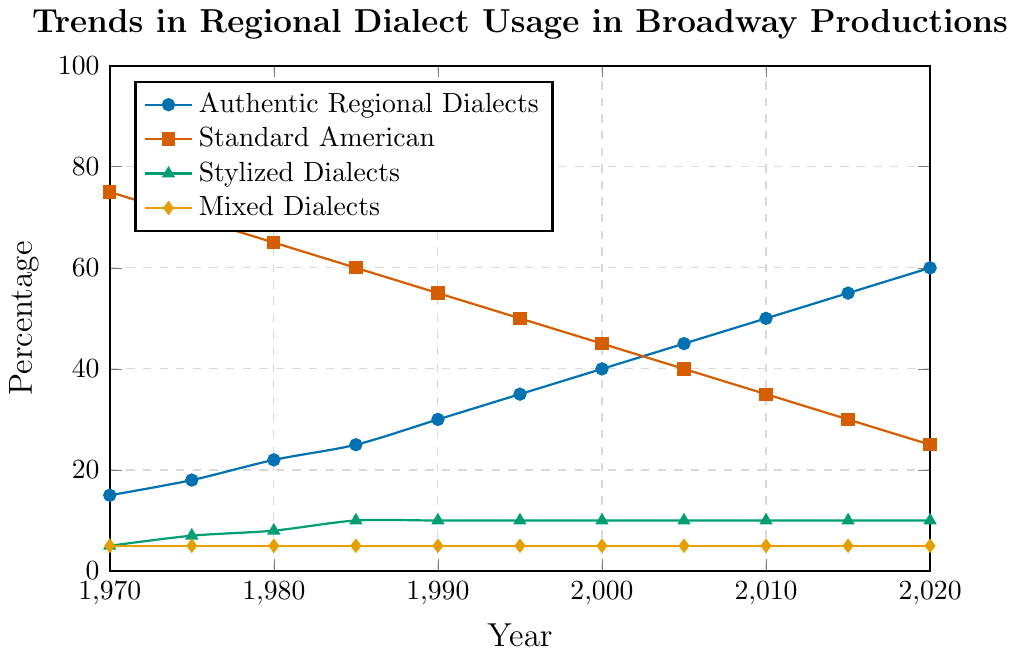What trend can be observed for the use of Authentic Regional Dialects from 1970 to 2020? The line representing Authentic Regional Dialects shows an upward trend, starting at 15% in 1970 and increasing steadily to 60% in 2020.
Answer: Increasing Which year did Standard American fall to 50% usage? The plot shows that Standard American usage was 50% in the year 1995.
Answer: 1995 Compare the usage of Stylized Dialects and Mixed Dialects over the years. Which dialect had consistent usage, and what was the percentage? Both Stylized Dialects and Mixed Dialects had consistent usage over the years. Stylized Dialects stayed around 10%, and Mixed Dialects stayed around 5%.
Answer: Both, 10% and 5% In which decade did Authentic Regional Dialects first surpass 30% usage? Authentic Regional Dialects first surpassed 30% usage in the 1990s. Specifically, by 1990, it reached 30%.
Answer: 1990s By how much did the usage of Standard American decline between 1970 and 2020? The usage of Standard American declined from 75% in 1970 to 25% in 2020. The decline is calculated as 75% - 25% = 50%.
Answer: 50% What is the total percentage use of all dialects combined in the year 2000? Summing up the percentages for all dialects in 2000, we get Authentic Regional Dialects (40%) + Standard American (45%) + Stylized Dialects (10%) + Mixed Dialects (5%) = 40% + 45% + 10% + 5% = 100%.
Answer: 100% How does the trend for Standard American compare visually with that of Authentic Regional Dialects over the entire period? Visually, the trend for Standard American shows a sharp decline, indicated by a downward slope from 75% to 25%. In contrast, Authentic Regional Dialects show a steady increase, indicated by an upward slope from 15% to 60%.
Answer: Standard American decreases, Authentic Regional increases Which dialect saw no change in its percentage usage from 1970 to 2020? The line plot shows that Mixed Dialects remained consistently at 5%, indicating no change.
Answer: Mixed Dialects Calculate the average percentage of Authentic Regional Dialects usage over the entire period from 1970 to 2020. Summing the usage percentages: (15 + 18 + 22 + 25 + 30 + 35 + 40 + 45 + 50 + 55 + 60) = 395. There are 11 data points. The average is 395 / 11 ≈ 35.91%.
Answer: 35.91% During which period did the percentage of Standard American and Authentic Regional Dialects usage become equal? The plot shows that around the year 2000, both Standard American and Authentic Regional Dialects usage converge at 45%.
Answer: Around 2000 